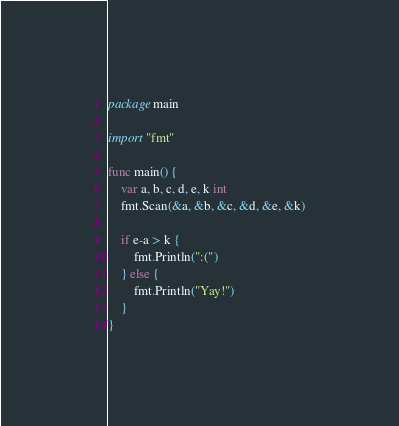Convert code to text. <code><loc_0><loc_0><loc_500><loc_500><_Go_>package main

import "fmt"

func main() {
	var a, b, c, d, e, k int
	fmt.Scan(&a, &b, &c, &d, &e, &k)

	if e-a > k {
		fmt.Println(":(")
	} else {
		fmt.Println("Yay!")
	}
}
</code> 